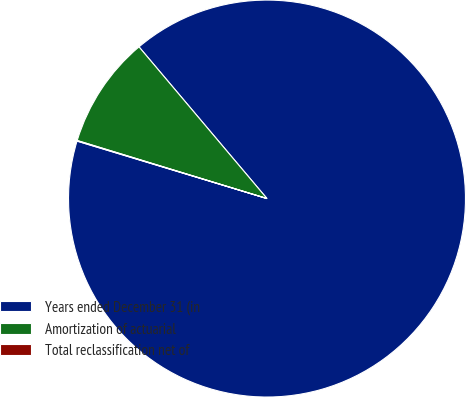Convert chart. <chart><loc_0><loc_0><loc_500><loc_500><pie_chart><fcel>Years ended December 31 (in<fcel>Amortization of actuarial<fcel>Total reclassification net of<nl><fcel>90.83%<fcel>9.12%<fcel>0.05%<nl></chart> 